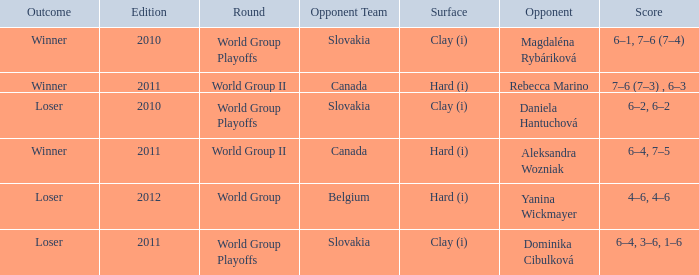What was the score when the opponent was Dominika Cibulková? 6–4, 3–6, 1–6. 